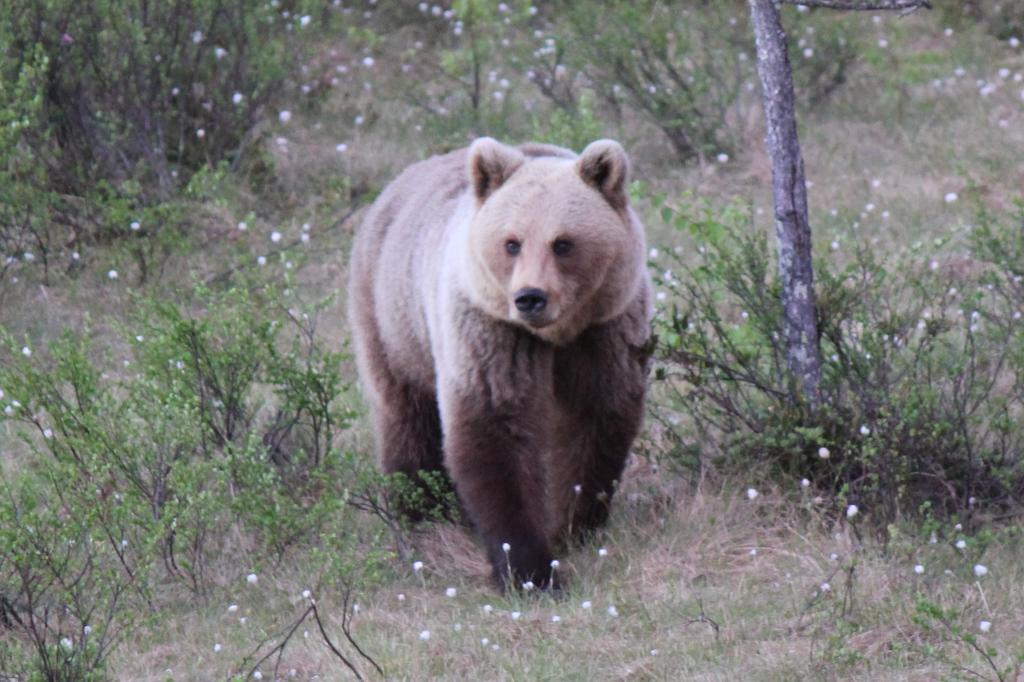What animal is present in the image? There is a bear in the image. Where is the bear located? The bear is on a grassland. What can be seen in the background of the image? There are plants in the background of the image. What type of sail can be seen on the bear in the image? There is no sail present in the image; it features a bear on a grassland with plants in the background. 